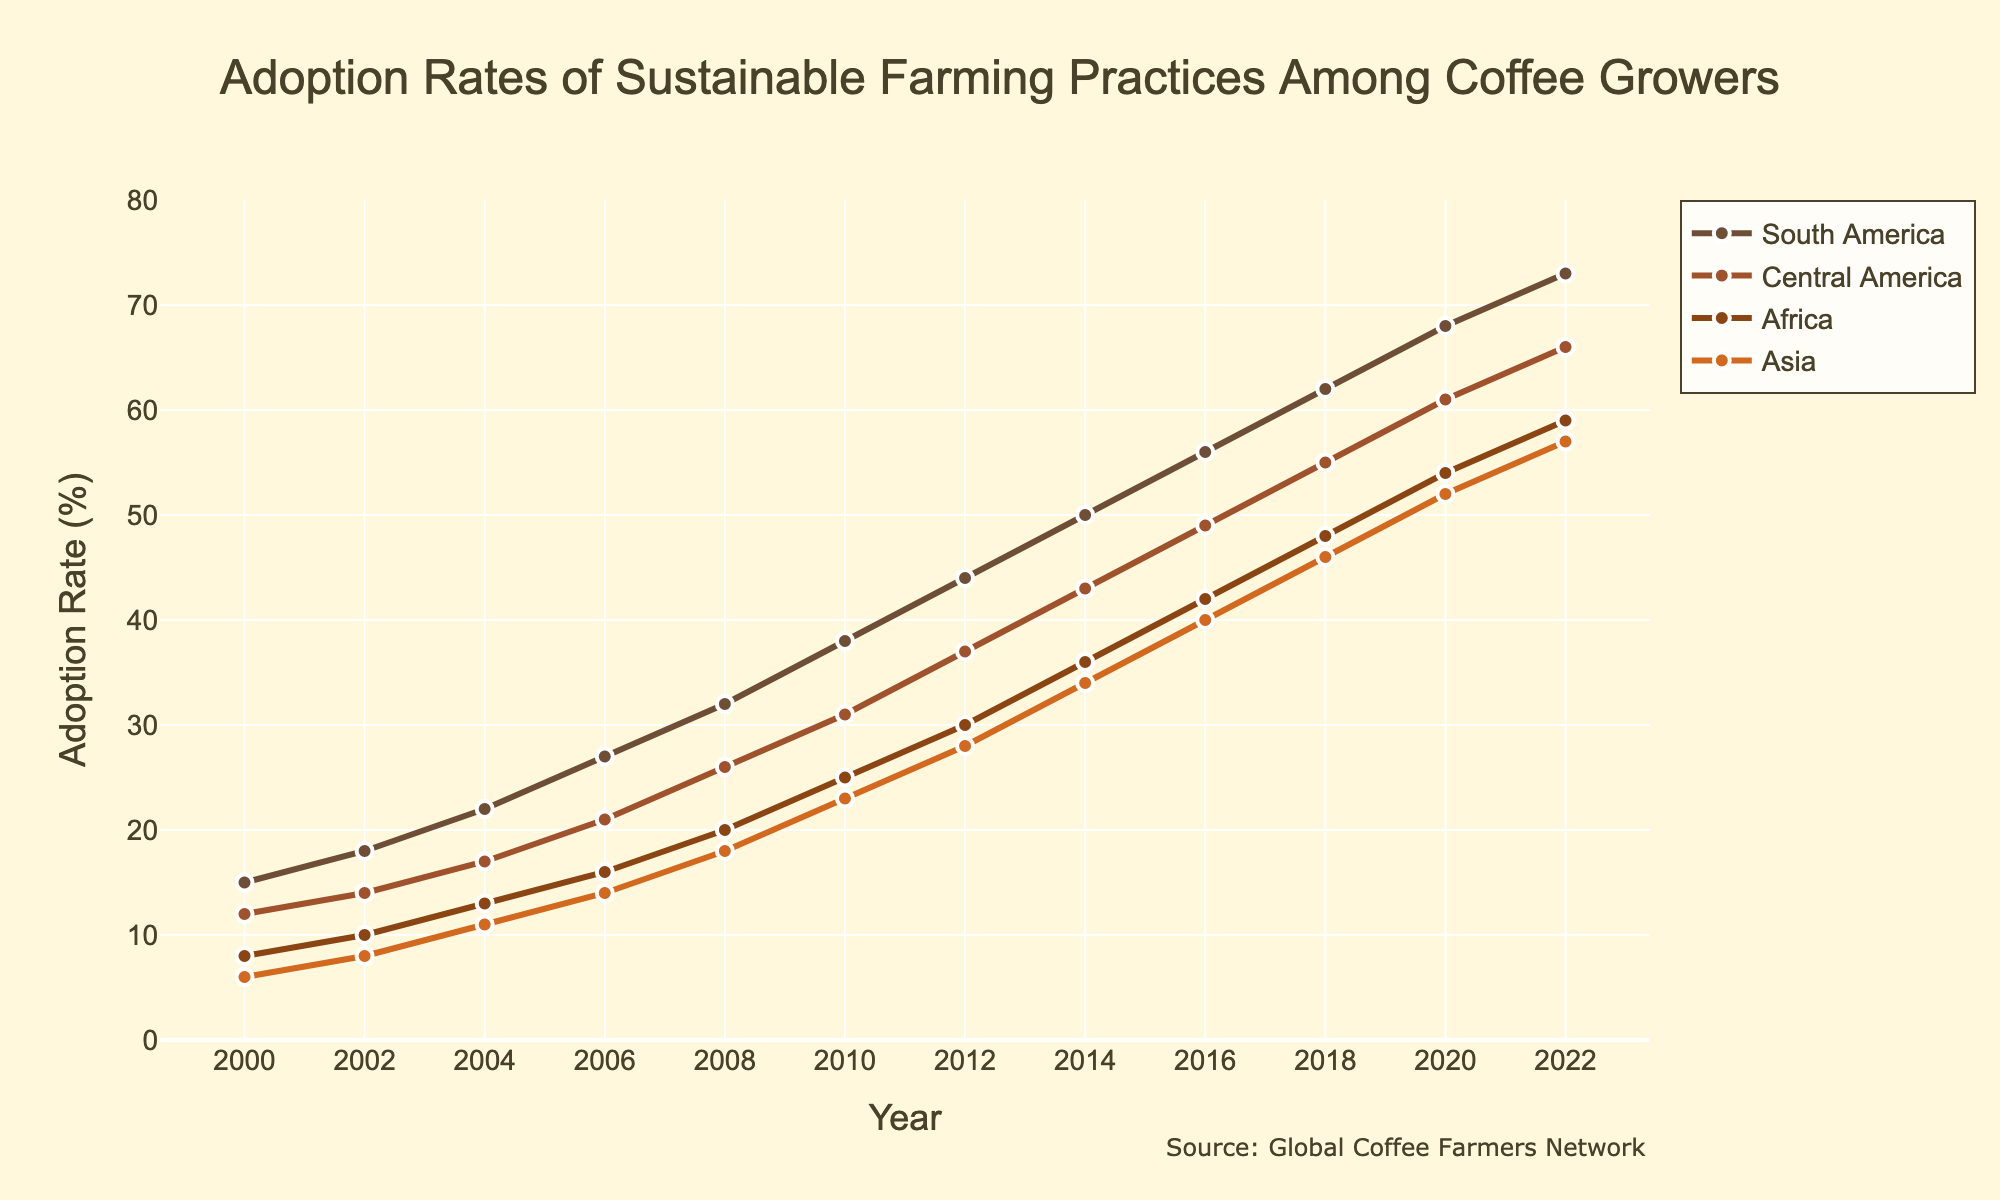What was the adoption rate of sustainable farming practices in South America in 2004? Locate the point above the year 2004 on the x-axis and see the corresponding y-axis value for South America. The point is at 22.
Answer: 22 Which continent had the highest adoption rate in 2022? Look at the points above the year 2022 on the x-axis and compare the y-axis values for all continents. South America's point is the highest.
Answer: South America What is the difference in adoption rates between Asia and Africa in 2010? Find the adoption rates for Asia and Africa in 2010 from the plotted points or the y-axis values. Asia (23) - Africa (25) = -2.
Answer: -2 Between 2000 and 2022, which continent saw the largest increase in adoption rates? Calculate the difference between the 2022 and 2000 adoption rates for each continent. South America increased from 15 to 73, Central America from 12 to 66, Africa from 8 to 59, and Asia from 6 to 57. South America's increase is the largest (73 - 15 = 58).
Answer: South America What was the average adoption rate in Central America from 2000 to 2022? Add adoption rates for Central America from each year (12+14+17+21+26+31+37+43+49+55+61+66 = 432) and divide by the number of years (432/12 = 36).
Answer: 36 How did the adoption rate in Africa change from 2008 to 2018? Find the adoption rates in Africa for 2008 (20) and 2018 (48) and subtract the earlier value from the later value (48 - 20 = 28).
Answer: 28 Which continent had a higher adoption rate in 2016, Central America or Africa? Check the values for Central America and Africa in 2016. Central America is 49, and Africa is 42. Central America's adoption rate is higher.
Answer: Central America Between 2014 and 2016, which continent experienced the steepest increase in adoption rates? Calculate the increases for each continent between 2014 and 2016: South America (56-50 = 6), Central America (49-43 = 6), Africa (42-36 = 6), and Asia (40-34 = 6). The increases are equal for all continents.
Answer: All continents equally What is the overall trend in the adoption rates for sustainable farming practices in Asia from 2000 to 2022? Observe the plotted points for Asia from 2000 to 2022 which show a consistently increasing trend.
Answer: Increasing Which continent had closer adoption rates to Africa in the year 2002? Find the adoption rates for 2002: Africa (10), other continents South America (18), Central America (14), Asia (8). Asia's adoption rate (8) is closest to Africa's (10).
Answer: Asia 